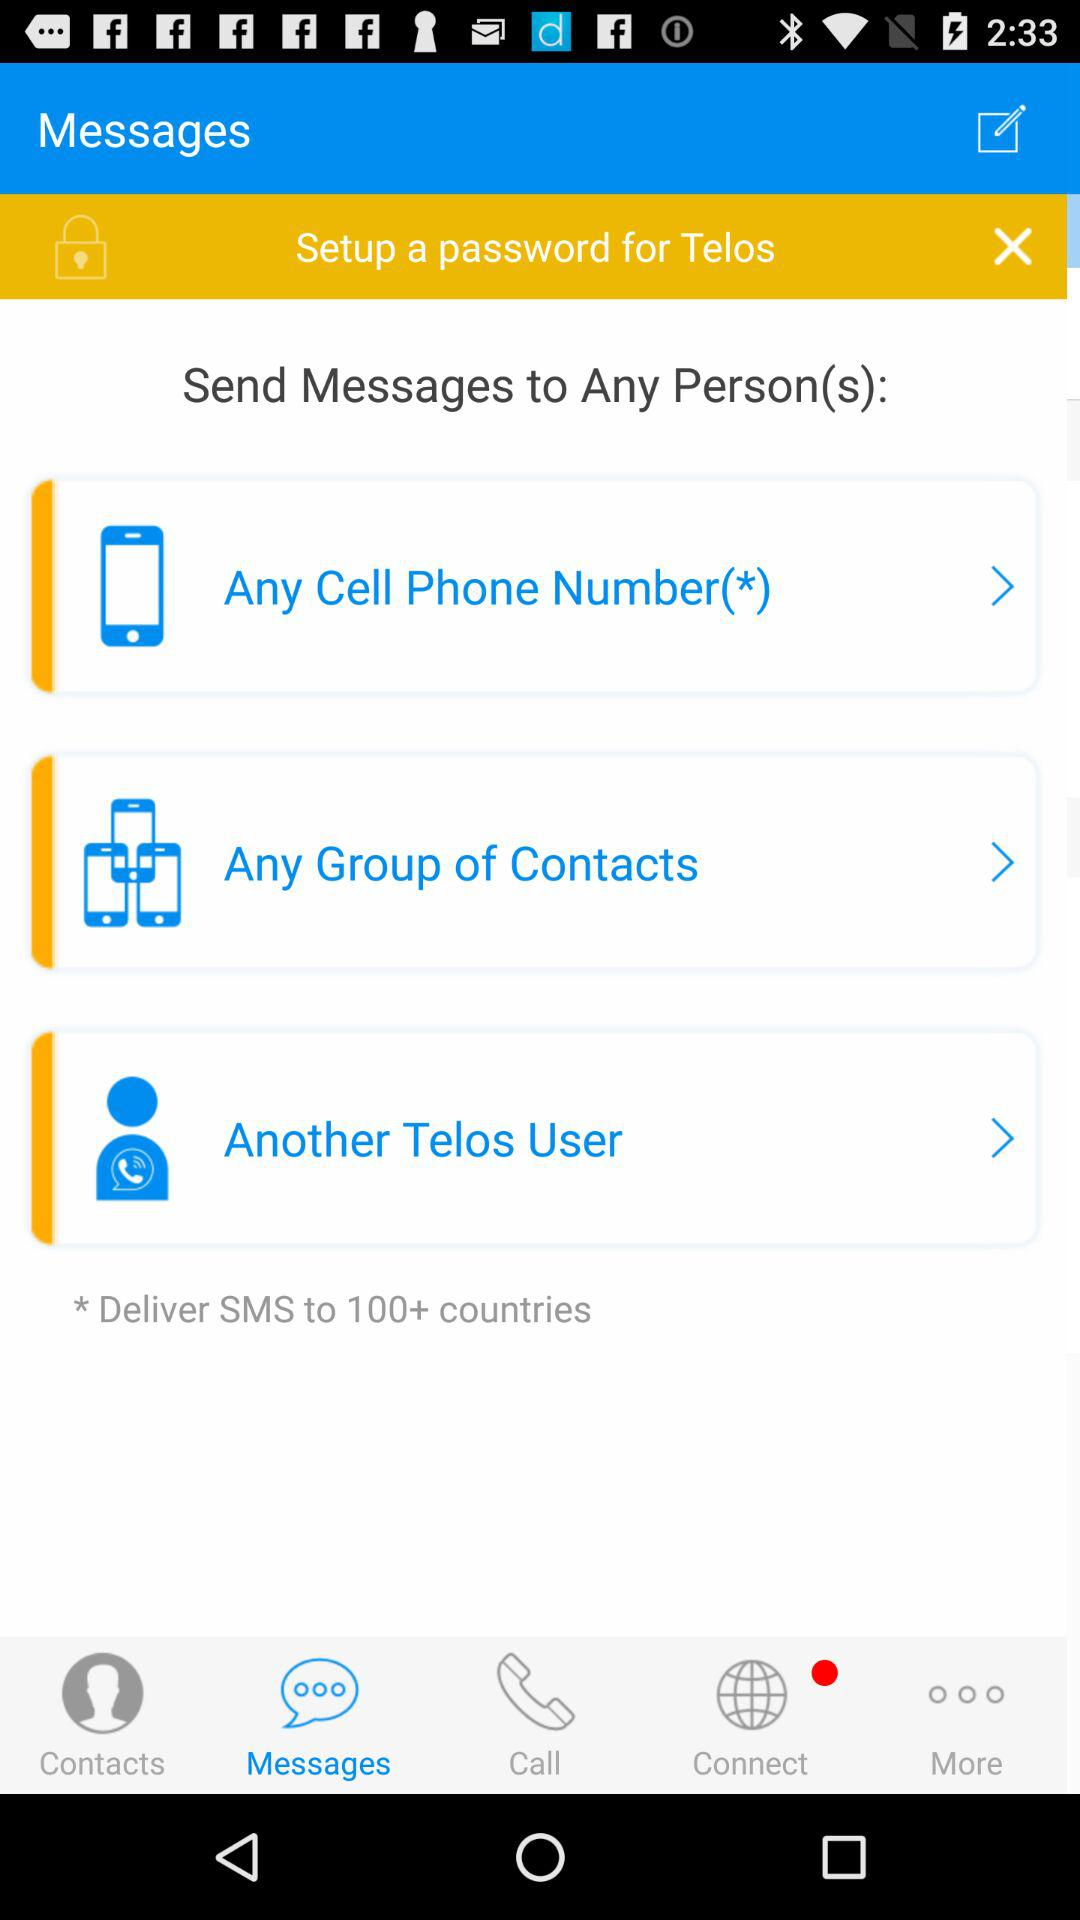What is the cell phone number?
When the provided information is insufficient, respond with <no answer>. <no answer> 